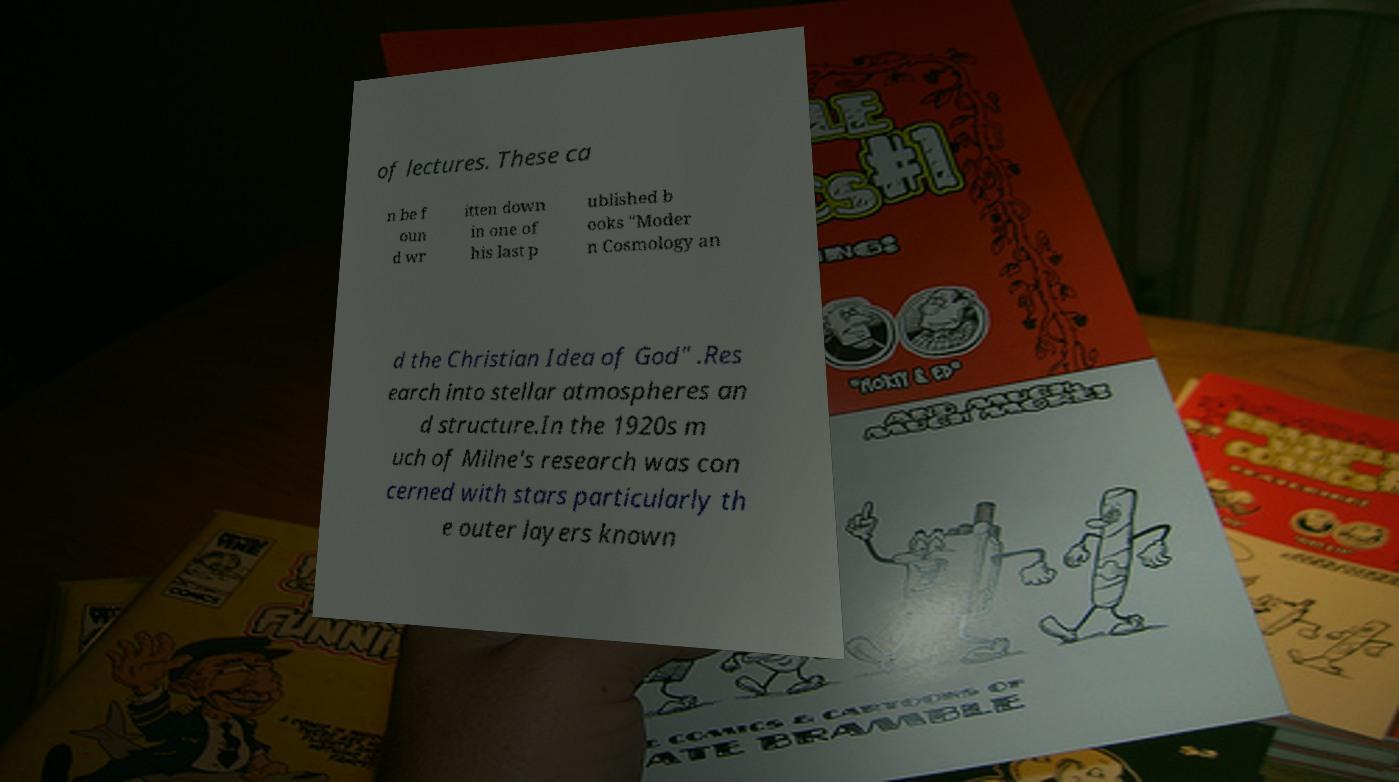What messages or text are displayed in this image? I need them in a readable, typed format. of lectures. These ca n be f oun d wr itten down in one of his last p ublished b ooks "Moder n Cosmology an d the Christian Idea of God" .Res earch into stellar atmospheres an d structure.In the 1920s m uch of Milne's research was con cerned with stars particularly th e outer layers known 